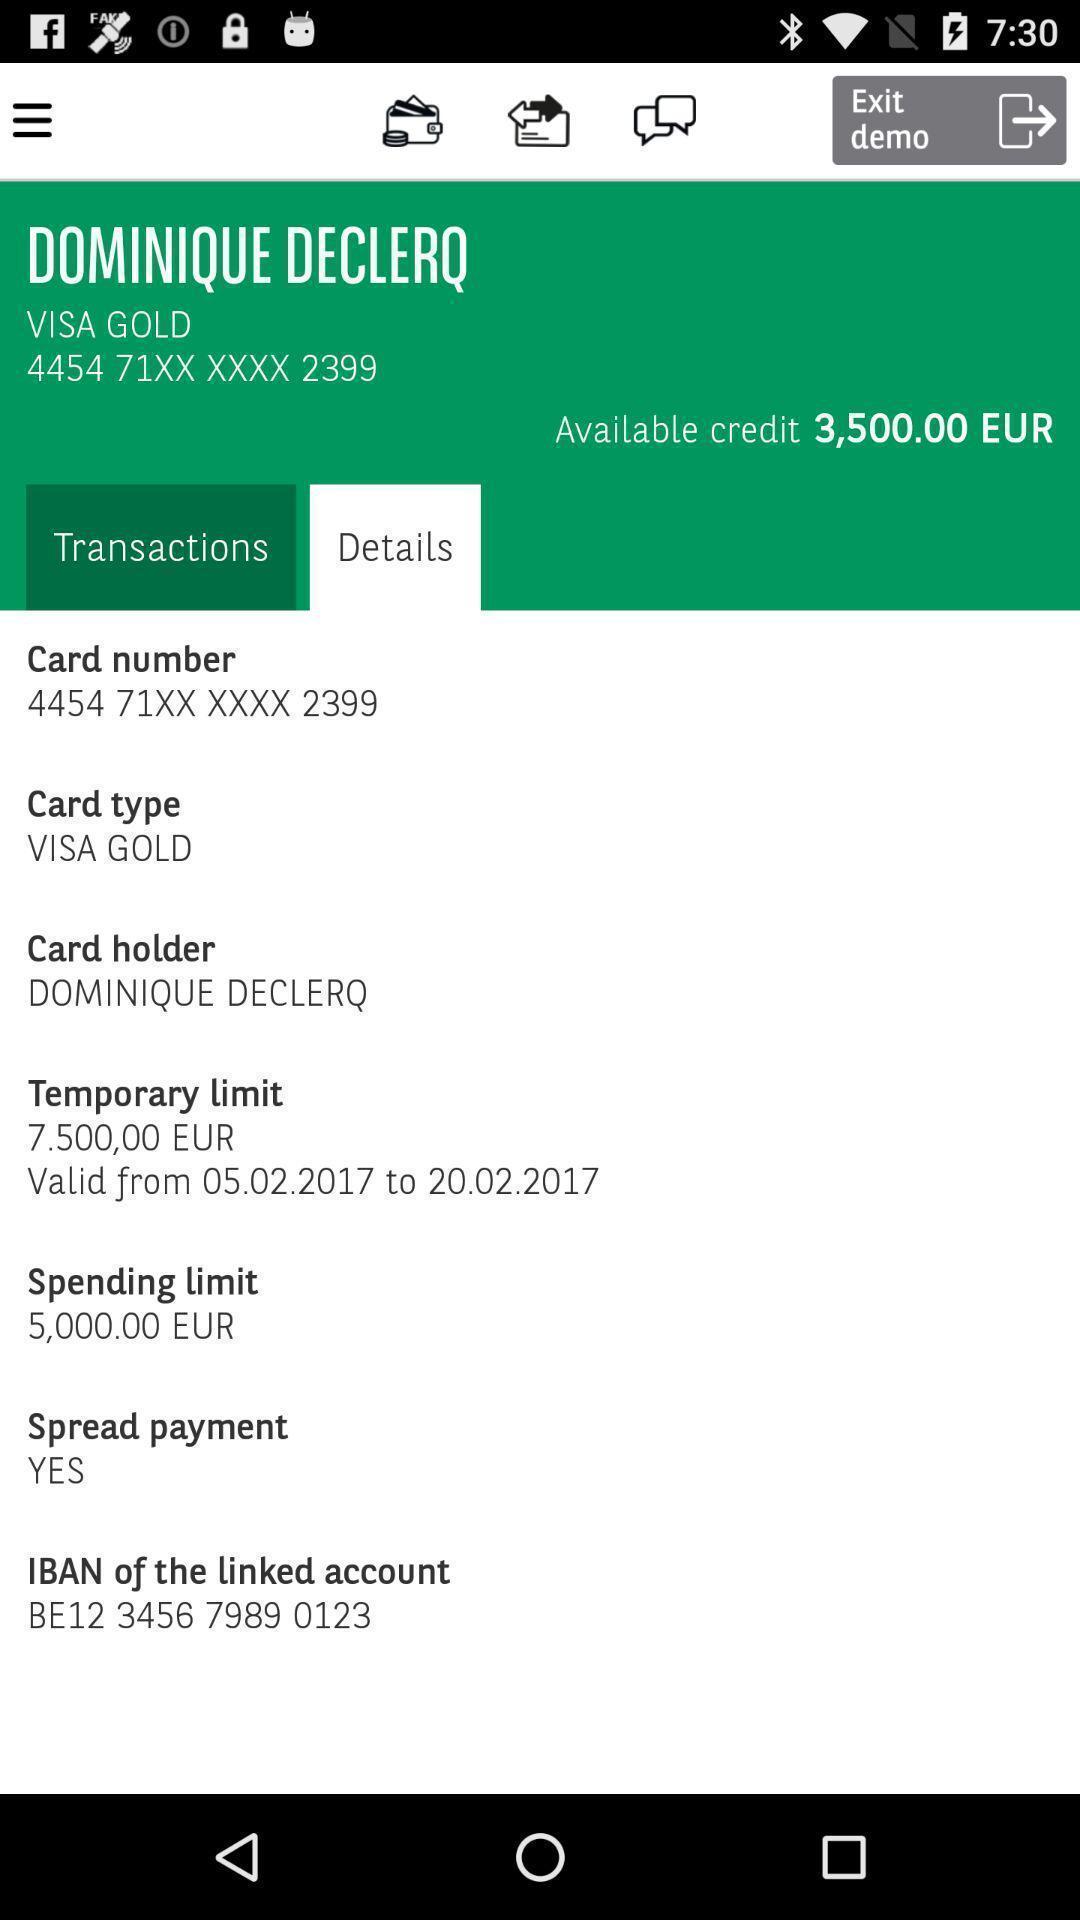Give me a summary of this screen capture. Page shows details of bank account. 